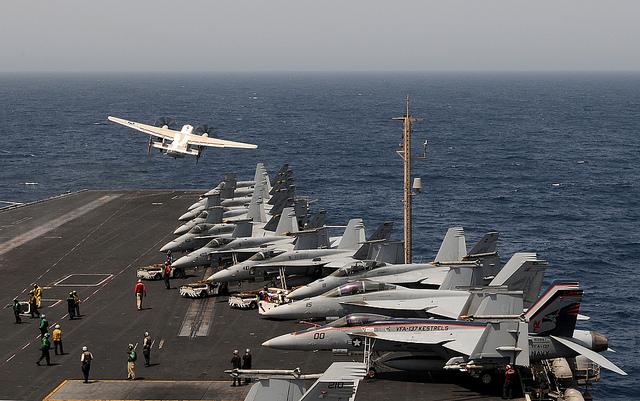Are the parked planes F-18's?
Short answer required. Yes. How many planes are in the air?
Answer briefly. 1. How many people are there?
Short answer required. 12. How many planes are shown?
Give a very brief answer. 11. 